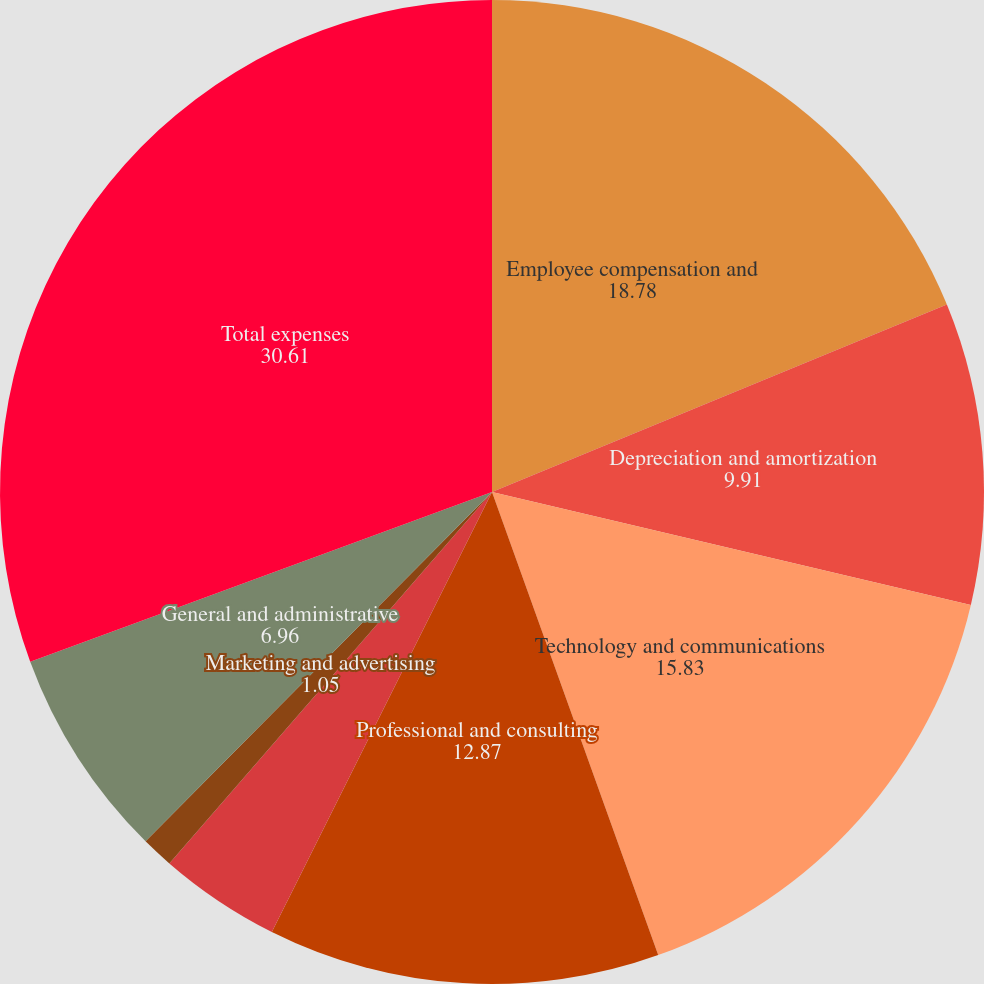Convert chart to OTSL. <chart><loc_0><loc_0><loc_500><loc_500><pie_chart><fcel>Employee compensation and<fcel>Depreciation and amortization<fcel>Technology and communications<fcel>Professional and consulting<fcel>Occupancy<fcel>Marketing and advertising<fcel>General and administrative<fcel>Total expenses<nl><fcel>18.78%<fcel>9.91%<fcel>15.83%<fcel>12.87%<fcel>4.0%<fcel>1.05%<fcel>6.96%<fcel>30.61%<nl></chart> 